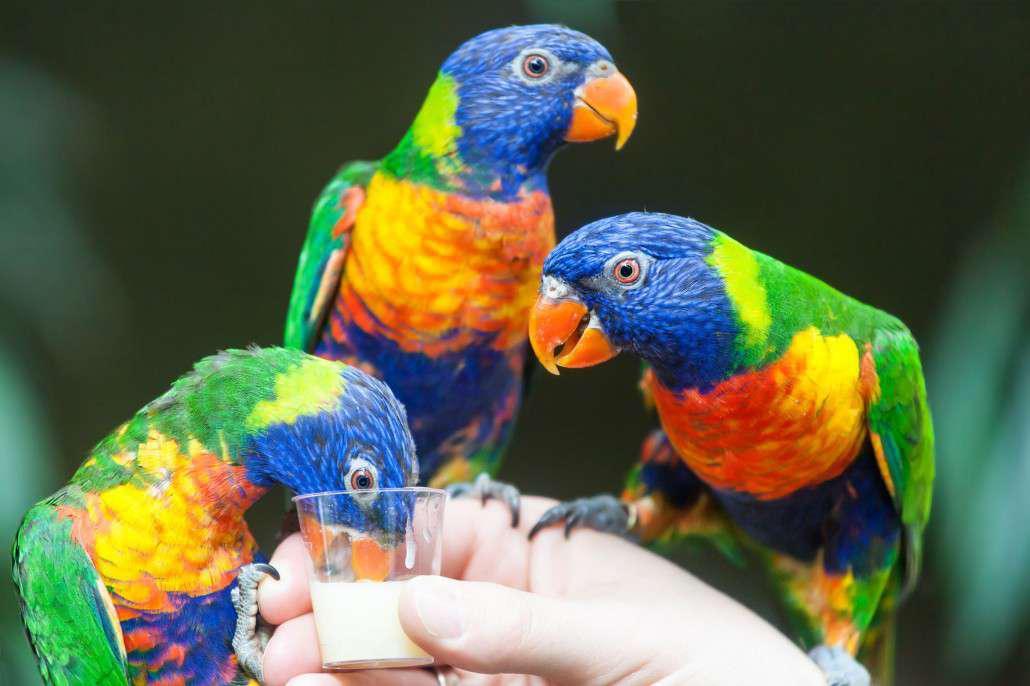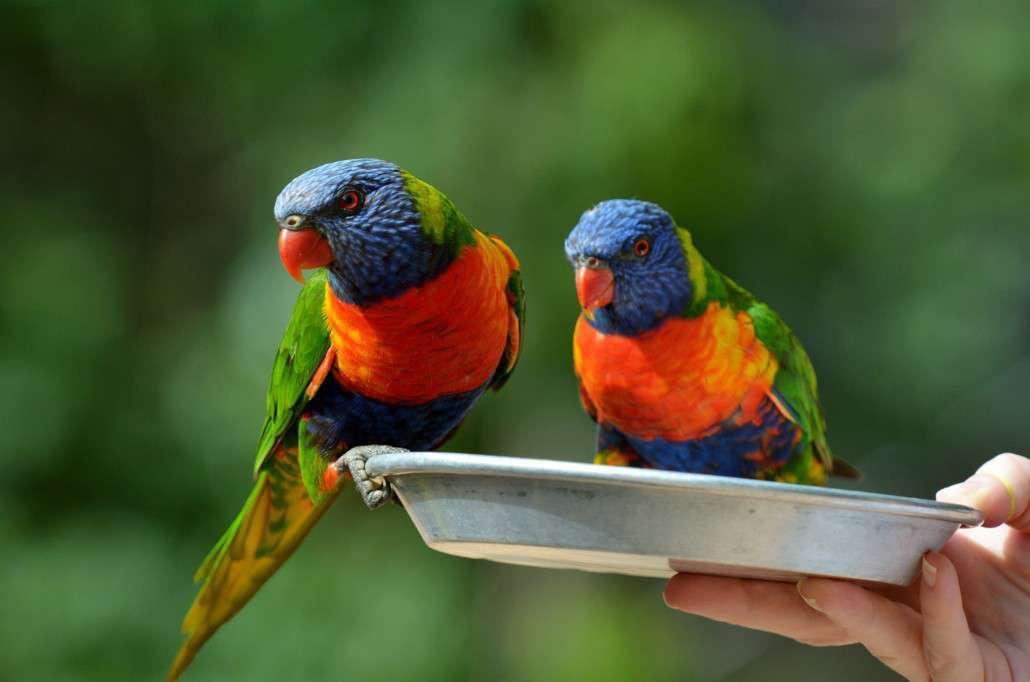The first image is the image on the left, the second image is the image on the right. For the images shown, is this caption "At least one parrot is perched on a human hand." true? Answer yes or no. Yes. The first image is the image on the left, the second image is the image on the right. Considering the images on both sides, is "The left image contains at least two parrots." valid? Answer yes or no. Yes. 